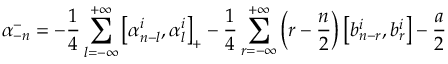Convert formula to latex. <formula><loc_0><loc_0><loc_500><loc_500>\alpha _ { - n } ^ { - } = - \frac { 1 } { 4 } \sum _ { l = - \infty } ^ { + \infty } \left [ \alpha _ { n - l } ^ { i } , \alpha _ { l } ^ { i } \right ] _ { + } - \frac { 1 } { 4 } \sum _ { r = - \infty } ^ { + \infty } \left ( r - \frac { n } { 2 } \right ) \left [ b _ { n - r } ^ { i } , b _ { r } ^ { i } \right ] - \frac { a } { 2 }</formula> 